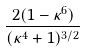<formula> <loc_0><loc_0><loc_500><loc_500>\frac { 2 ( 1 - \kappa ^ { 6 } ) } { ( \kappa ^ { 4 } + 1 ) ^ { 3 / 2 } }</formula> 